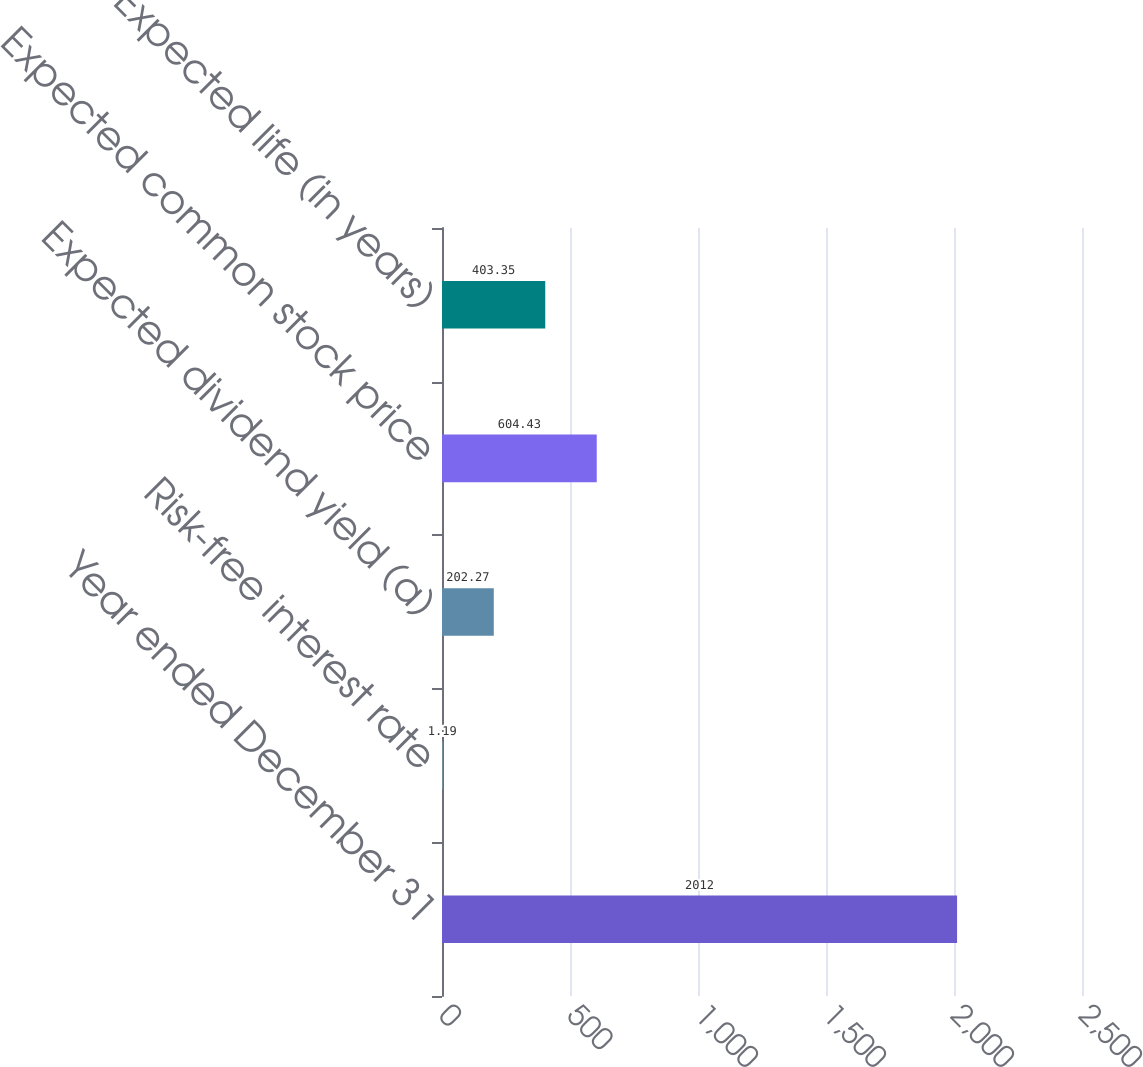Convert chart to OTSL. <chart><loc_0><loc_0><loc_500><loc_500><bar_chart><fcel>Year ended December 31<fcel>Risk-free interest rate<fcel>Expected dividend yield (a)<fcel>Expected common stock price<fcel>Expected life (in years)<nl><fcel>2012<fcel>1.19<fcel>202.27<fcel>604.43<fcel>403.35<nl></chart> 